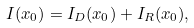Convert formula to latex. <formula><loc_0><loc_0><loc_500><loc_500>I ( x _ { 0 } ) = I _ { D } ( x _ { 0 } ) + I _ { R } ( x _ { 0 } ) ,</formula> 